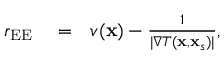<formula> <loc_0><loc_0><loc_500><loc_500>\begin{array} { r l r } { r _ { E E } } & = } & { v ( x ) - \frac { 1 } { | \nabla T ( x , x _ { s } ) | } , } \end{array}</formula> 